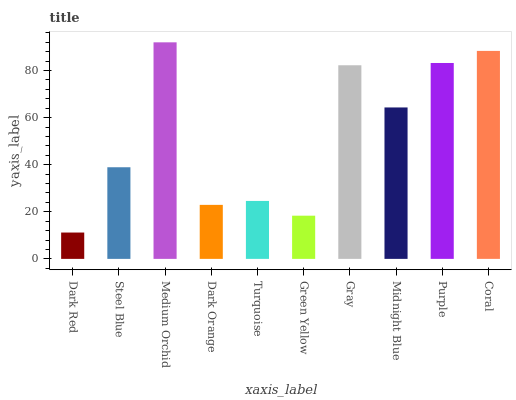Is Dark Red the minimum?
Answer yes or no. Yes. Is Medium Orchid the maximum?
Answer yes or no. Yes. Is Steel Blue the minimum?
Answer yes or no. No. Is Steel Blue the maximum?
Answer yes or no. No. Is Steel Blue greater than Dark Red?
Answer yes or no. Yes. Is Dark Red less than Steel Blue?
Answer yes or no. Yes. Is Dark Red greater than Steel Blue?
Answer yes or no. No. Is Steel Blue less than Dark Red?
Answer yes or no. No. Is Midnight Blue the high median?
Answer yes or no. Yes. Is Steel Blue the low median?
Answer yes or no. Yes. Is Dark Orange the high median?
Answer yes or no. No. Is Purple the low median?
Answer yes or no. No. 